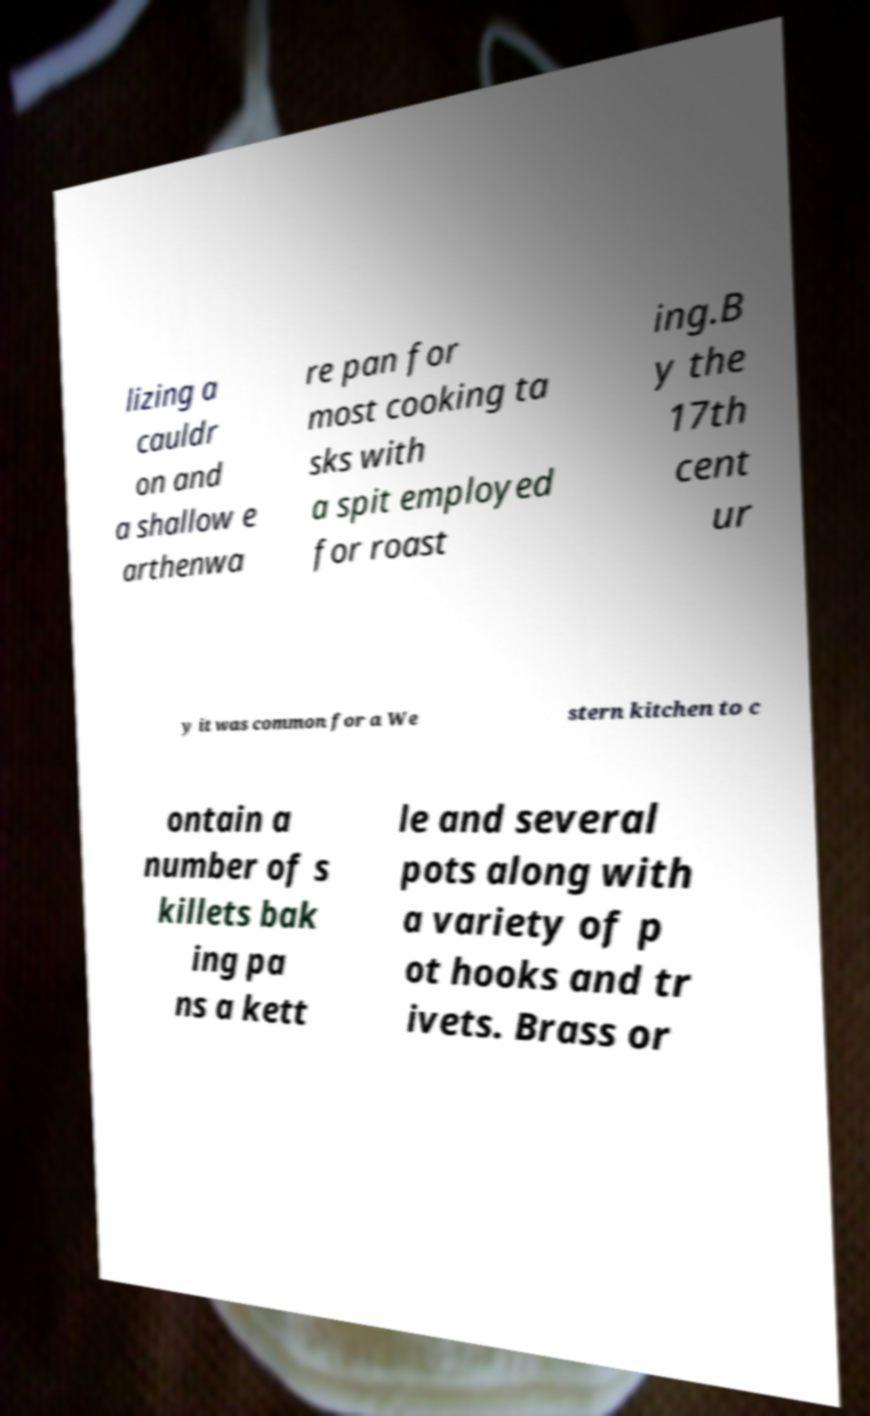There's text embedded in this image that I need extracted. Can you transcribe it verbatim? lizing a cauldr on and a shallow e arthenwa re pan for most cooking ta sks with a spit employed for roast ing.B y the 17th cent ur y it was common for a We stern kitchen to c ontain a number of s killets bak ing pa ns a kett le and several pots along with a variety of p ot hooks and tr ivets. Brass or 